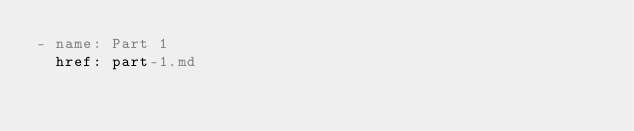<code> <loc_0><loc_0><loc_500><loc_500><_YAML_>- name: Part 1
  href: part-1.md</code> 